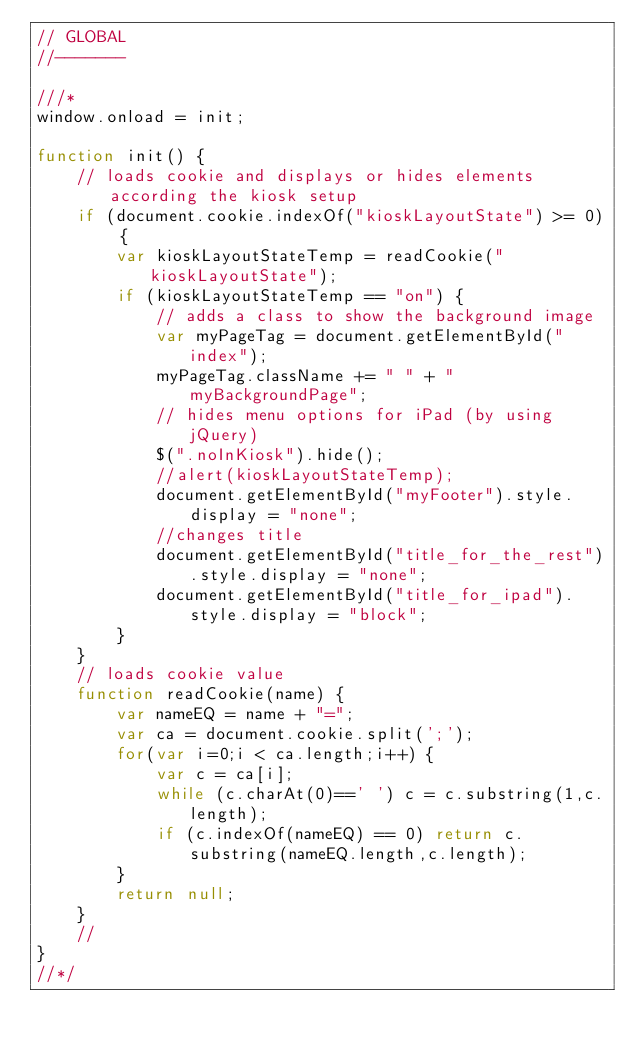<code> <loc_0><loc_0><loc_500><loc_500><_JavaScript_>// GLOBAL
//-------

///*
window.onload = init;

function init() {	
    // loads cookie and displays or hides elements according the kiosk setup
	if (document.cookie.indexOf("kioskLayoutState") >= 0) { 
		var kioskLayoutStateTemp = readCookie("kioskLayoutState");
		if (kioskLayoutStateTemp == "on") {
			// adds a class to show the background image
			var myPageTag = document.getElementById("index");
			myPageTag.className += " " + "myBackgroundPage";
			// hides menu options for iPad (by using jQuery)
			$(".noInKiosk").hide();
			//alert(kioskLayoutStateTemp);
			document.getElementById("myFooter").style.display = "none";
			//changes title 
			document.getElementById("title_for_the_rest").style.display = "none";
			document.getElementById("title_for_ipad").style.display = "block";
		}
	}
	// loads cookie value
	function readCookie(name) {
		var nameEQ = name + "=";
		var ca = document.cookie.split(';');
		for(var i=0;i < ca.length;i++) {
			var c = ca[i];
			while (c.charAt(0)==' ') c = c.substring(1,c.length);
			if (c.indexOf(nameEQ) == 0) return c.substring(nameEQ.length,c.length);
		}
		return null;
	}
	// 
}
//*/

</code> 